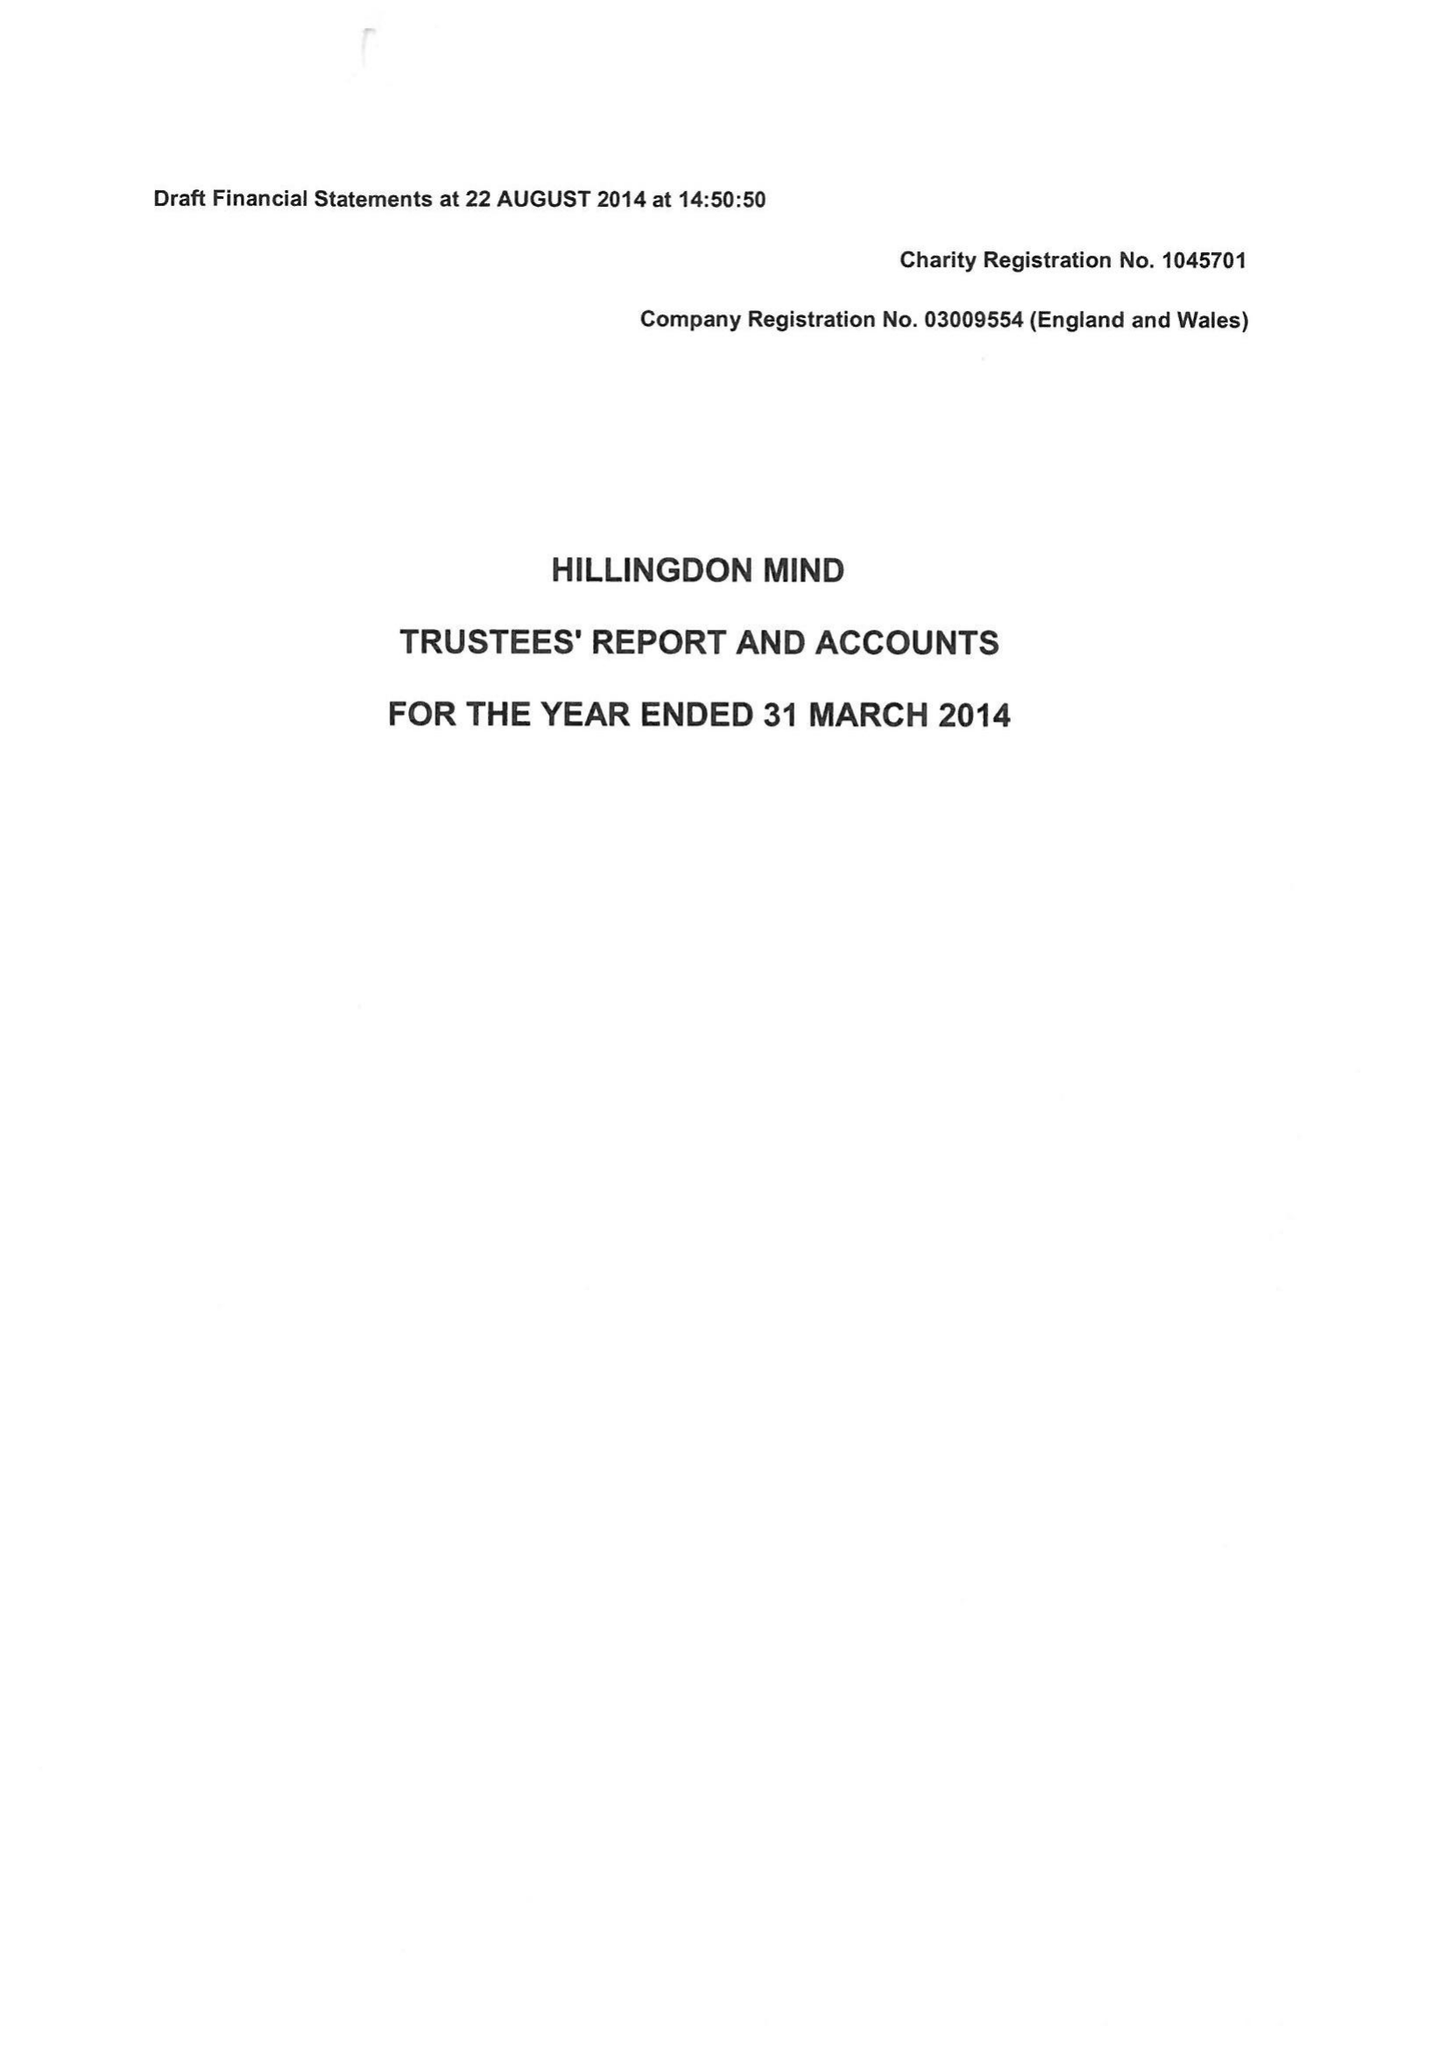What is the value for the address__postcode?
Answer the question using a single word or phrase. UB8 2TU 